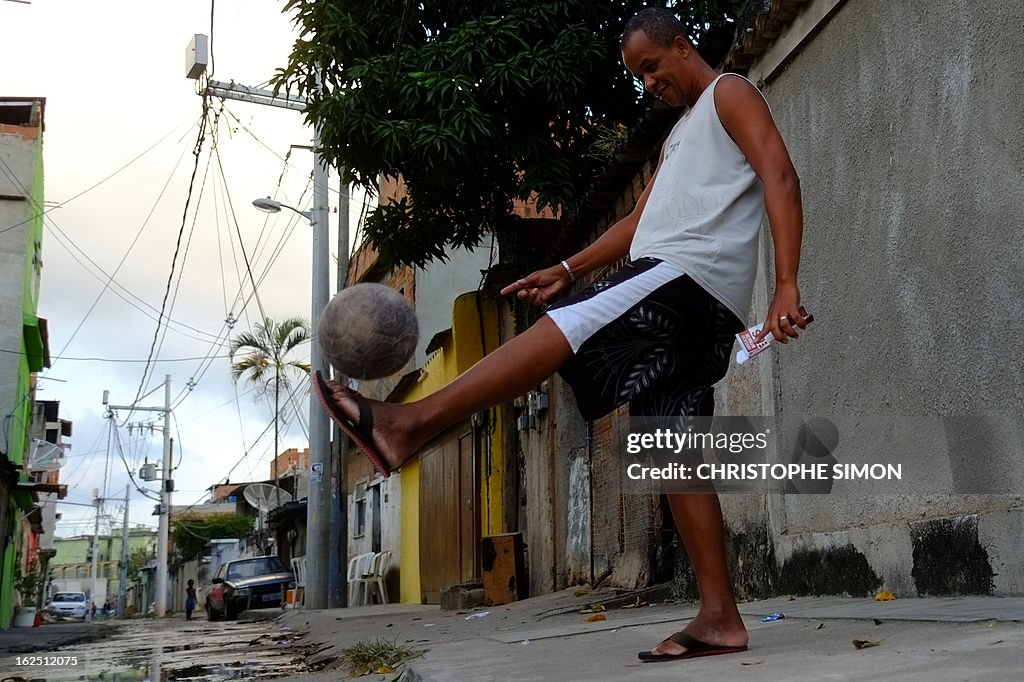Can you comment on the impact of socioeconomic factors on access to sports equipment and facilities as seen in this image? The image, featuring a well-worn soccer ball and a setting that lacks specialized sports facilities, subtly underscores socioeconomic influences on sports access. The player's use of minimal equipment and makeshift playing area highlights resourcefulness in less affluent environments. It points to a disparity in access to quality gear and facilities, prompting reliance on communal spaces and personal improvisation to engage in sports, which, while fostering community bonds, also reflects broader economic challenges. 